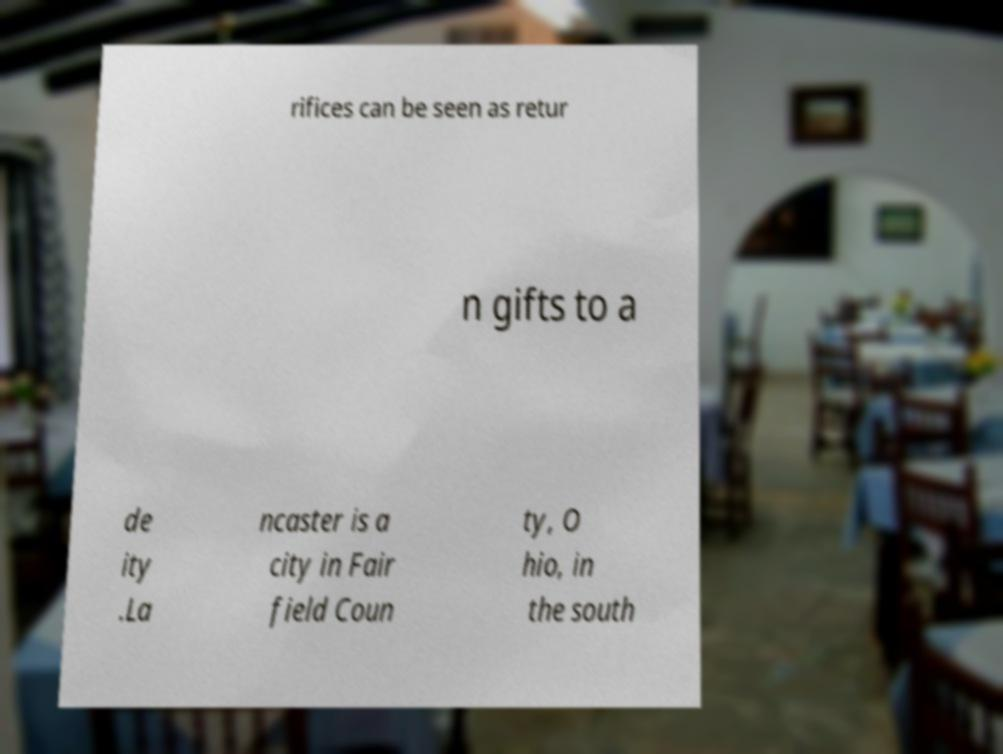I need the written content from this picture converted into text. Can you do that? rifices can be seen as retur n gifts to a de ity .La ncaster is a city in Fair field Coun ty, O hio, in the south 